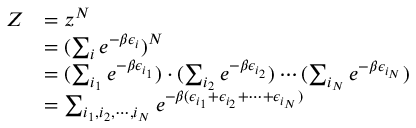Convert formula to latex. <formula><loc_0><loc_0><loc_500><loc_500>\begin{array} { r l } { Z } & { = z ^ { N } } \\ & { = ( \sum _ { i } e ^ { - \beta \epsilon _ { i } } ) ^ { N } } \\ & { = ( \sum _ { i _ { 1 } } e ^ { - \beta \epsilon _ { i _ { 1 } } } ) \cdot ( \sum _ { i _ { 2 } } e ^ { - \beta \epsilon _ { i _ { 2 } } } ) \cdots ( \sum _ { i _ { N } } e ^ { - \beta \epsilon _ { i _ { N } } } ) } \\ & { = \sum _ { i _ { 1 } , i _ { 2 } , \cdots , i _ { N } } e ^ { - \beta ( \epsilon _ { i _ { 1 } } + \epsilon _ { i _ { 2 } } + \cdots + \epsilon _ { i _ { N } } ) } } \end{array}</formula> 